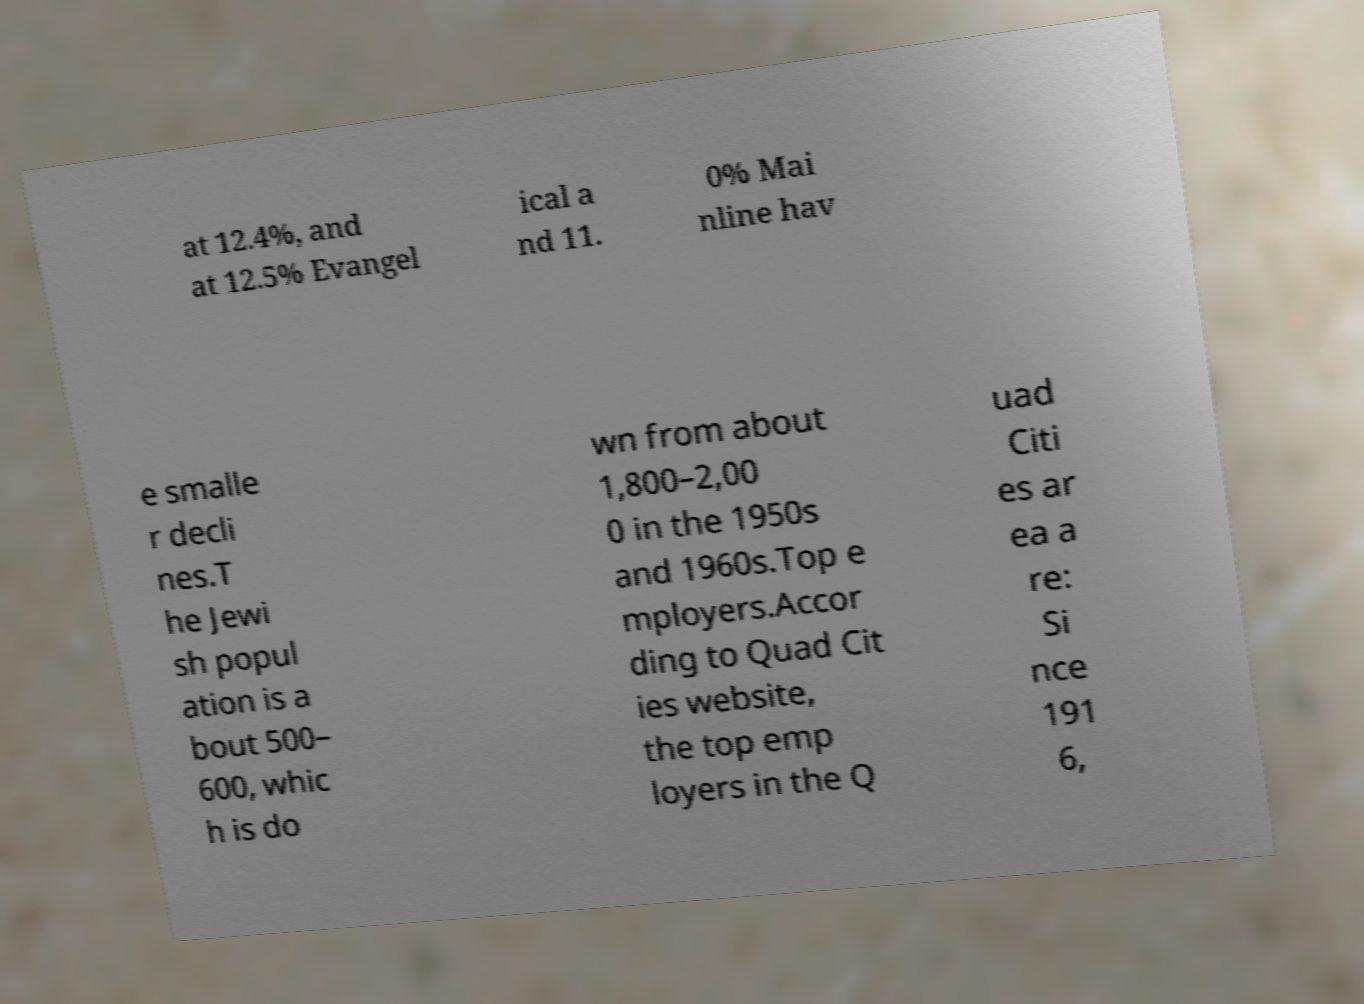For documentation purposes, I need the text within this image transcribed. Could you provide that? at 12.4%, and at 12.5% Evangel ical a nd 11. 0% Mai nline hav e smalle r decli nes.T he Jewi sh popul ation is a bout 500– 600, whic h is do wn from about 1,800–2,00 0 in the 1950s and 1960s.Top e mployers.Accor ding to Quad Cit ies website, the top emp loyers in the Q uad Citi es ar ea a re: Si nce 191 6, 